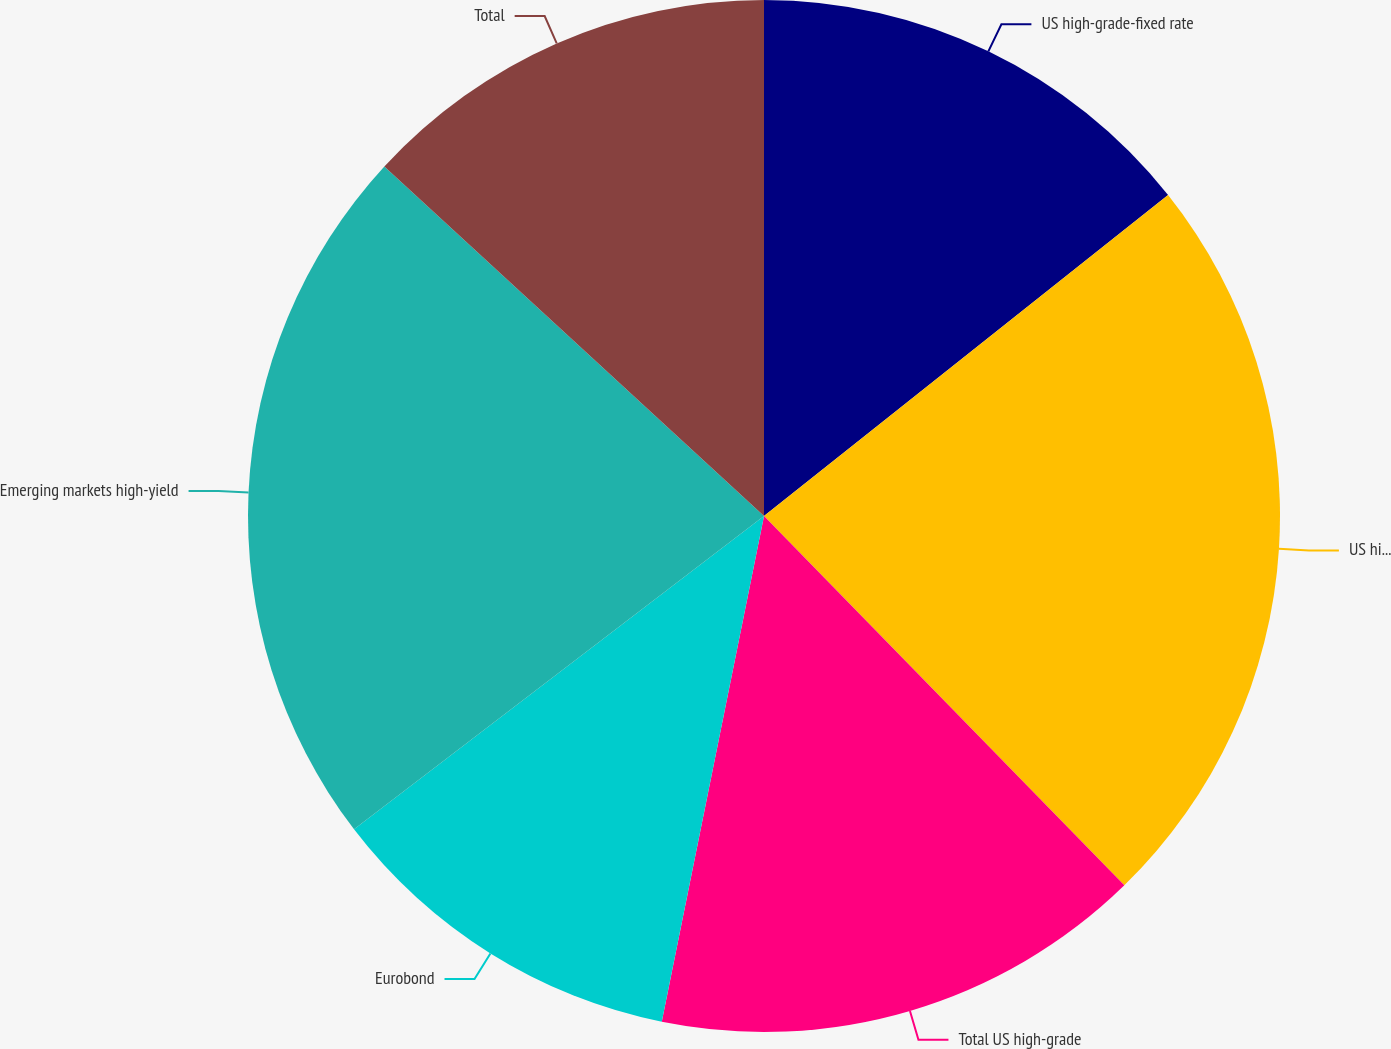<chart> <loc_0><loc_0><loc_500><loc_500><pie_chart><fcel>US high-grade-fixed rate<fcel>US high-grade-floating rate<fcel>Total US high-grade<fcel>Eurobond<fcel>Emerging markets high-yield<fcel>Total<nl><fcel>14.32%<fcel>23.38%<fcel>15.48%<fcel>11.44%<fcel>22.23%<fcel>13.16%<nl></chart> 